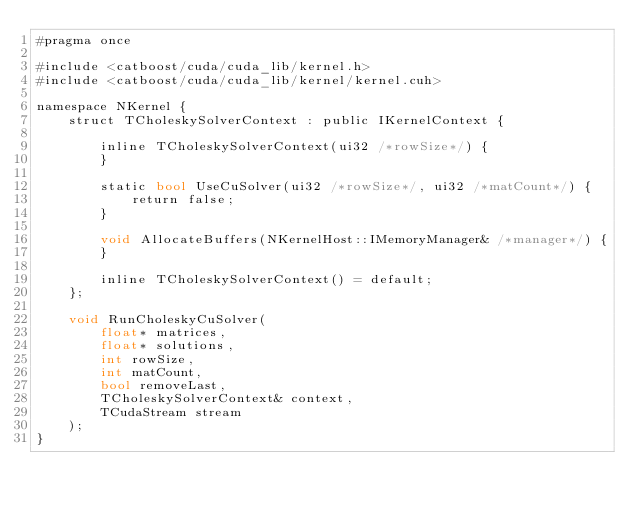<code> <loc_0><loc_0><loc_500><loc_500><_Cuda_>#pragma once

#include <catboost/cuda/cuda_lib/kernel.h>
#include <catboost/cuda/cuda_lib/kernel/kernel.cuh>

namespace NKernel {
    struct TCholeskySolverContext : public IKernelContext {

        inline TCholeskySolverContext(ui32 /*rowSize*/) {
        }

        static bool UseCuSolver(ui32 /*rowSize*/, ui32 /*matCount*/) {
            return false;
        }

        void AllocateBuffers(NKernelHost::IMemoryManager& /*manager*/) {
        }

        inline TCholeskySolverContext() = default;
    };

    void RunCholeskyCuSolver(
        float* matrices,
        float* solutions,
        int rowSize,
        int matCount,
        bool removeLast,
        TCholeskySolverContext& context,
        TCudaStream stream
    );
}
</code> 